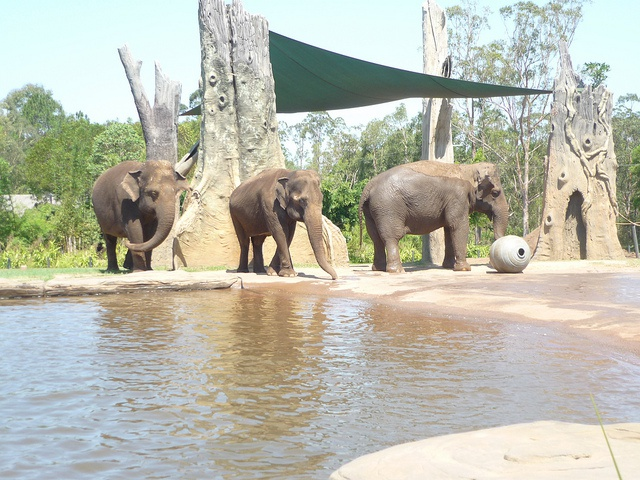Describe the objects in this image and their specific colors. I can see elephant in lightblue, darkgray, gray, and tan tones, elephant in lightblue, gray, black, and tan tones, and elephant in lightblue, gray, black, and tan tones in this image. 